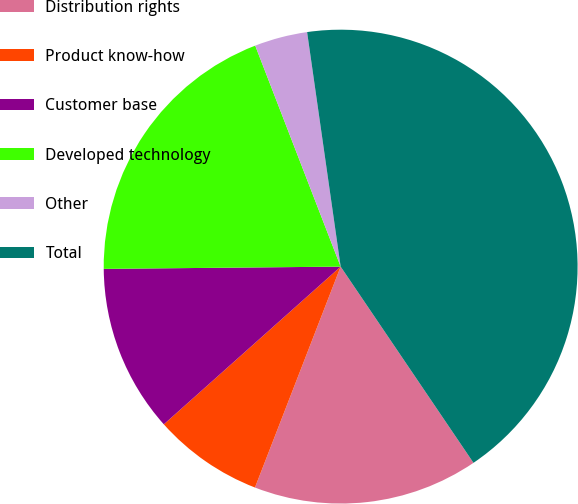<chart> <loc_0><loc_0><loc_500><loc_500><pie_chart><fcel>Distribution rights<fcel>Product know-how<fcel>Customer base<fcel>Developed technology<fcel>Other<fcel>Total<nl><fcel>15.36%<fcel>7.52%<fcel>11.44%<fcel>19.28%<fcel>3.61%<fcel>42.79%<nl></chart> 